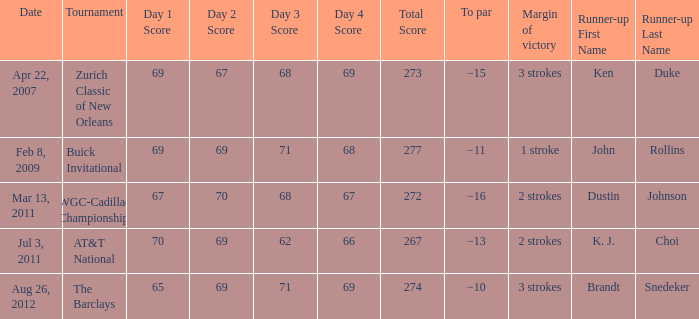What was the margin of victory when Brandt Snedeker was runner-up? 3 strokes. 